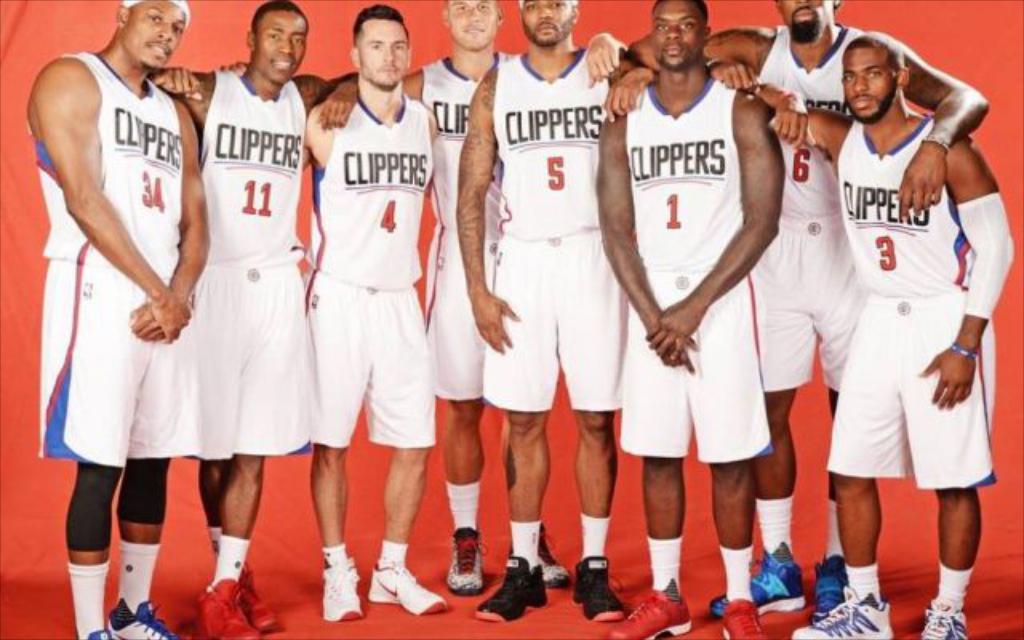What team is this?
Your response must be concise. Clippers. What is the man on the far rights jersey number?
Offer a terse response. 3. 